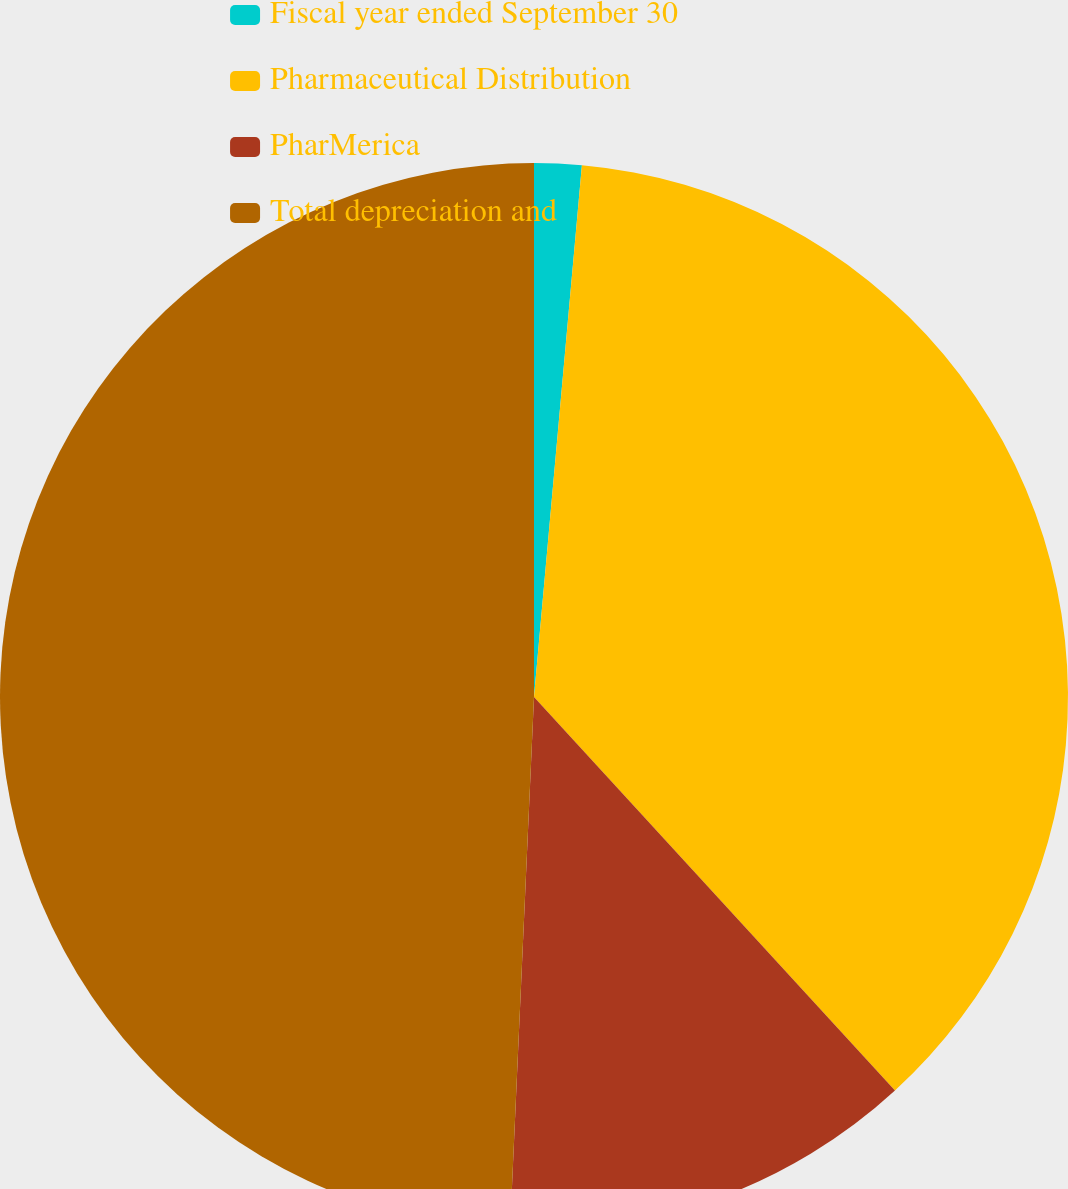Convert chart to OTSL. <chart><loc_0><loc_0><loc_500><loc_500><pie_chart><fcel>Fiscal year ended September 30<fcel>Pharmaceutical Distribution<fcel>PharMerica<fcel>Total depreciation and<nl><fcel>1.43%<fcel>36.76%<fcel>12.53%<fcel>49.29%<nl></chart> 